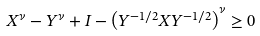Convert formula to latex. <formula><loc_0><loc_0><loc_500><loc_500>X ^ { \nu } - Y ^ { \nu } + I - \left ( Y ^ { - 1 / 2 } X Y ^ { - 1 / 2 } \right ) ^ { \nu } \geq 0</formula> 